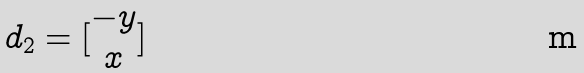Convert formula to latex. <formula><loc_0><loc_0><loc_500><loc_500>d _ { 2 } = [ \begin{matrix} - y \\ x \\ \end{matrix} ]</formula> 